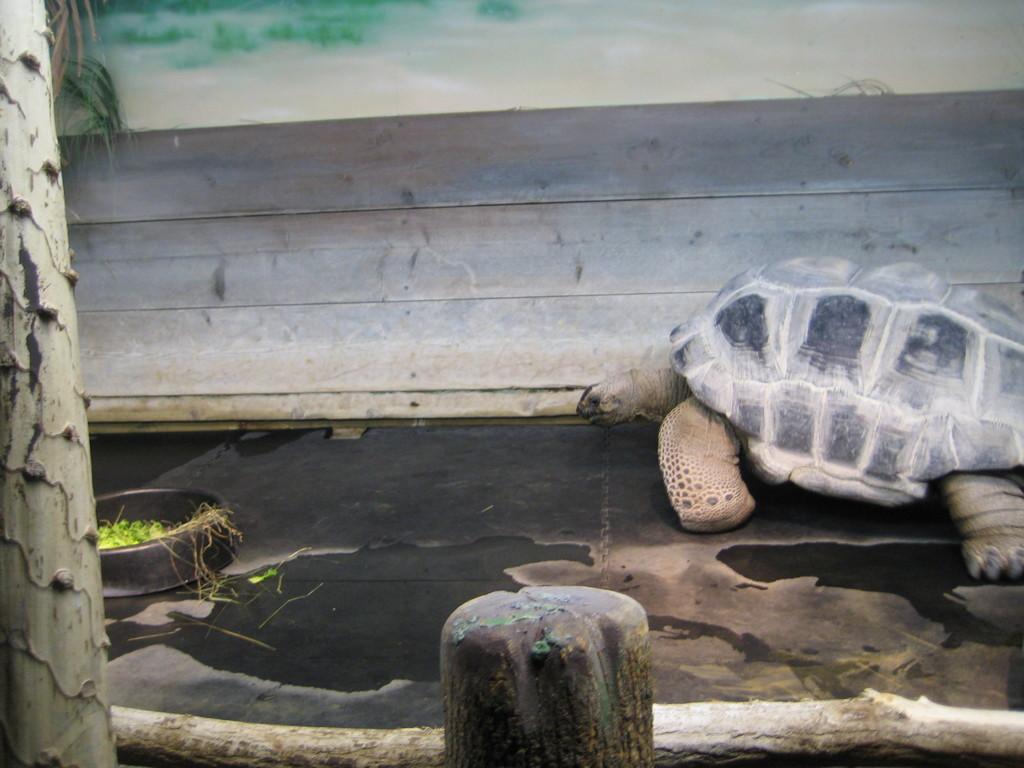In one or two sentences, can you explain what this image depicts? Here in this picture we can see a tortoise present on the ground over there and in front of it we can see a box having some food in it and beside that we can see a wooden plank present and in the front we can see a wooden railing and a pole present over there. 